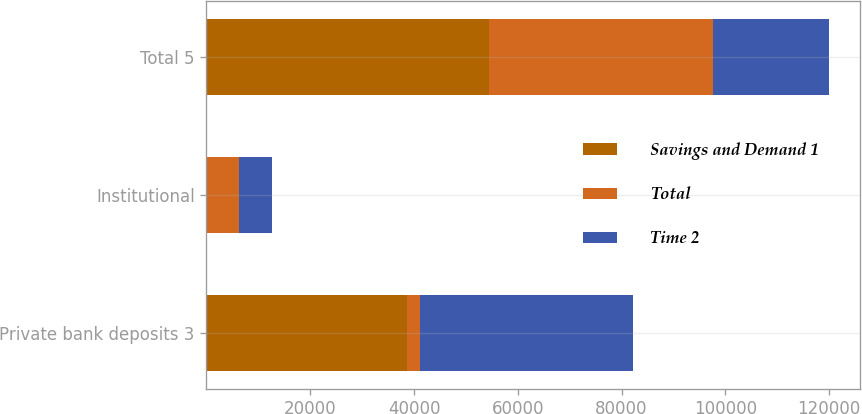Convert chart to OTSL. <chart><loc_0><loc_0><loc_500><loc_500><stacked_bar_chart><ecel><fcel>Private bank deposits 3<fcel>Institutional<fcel>Total 5<nl><fcel>Savings and Demand 1<fcel>38715<fcel>1<fcel>54507<nl><fcel>Total<fcel>2354<fcel>6283<fcel>43012<nl><fcel>Time 2<fcel>41069<fcel>6284<fcel>22499.5<nl></chart> 